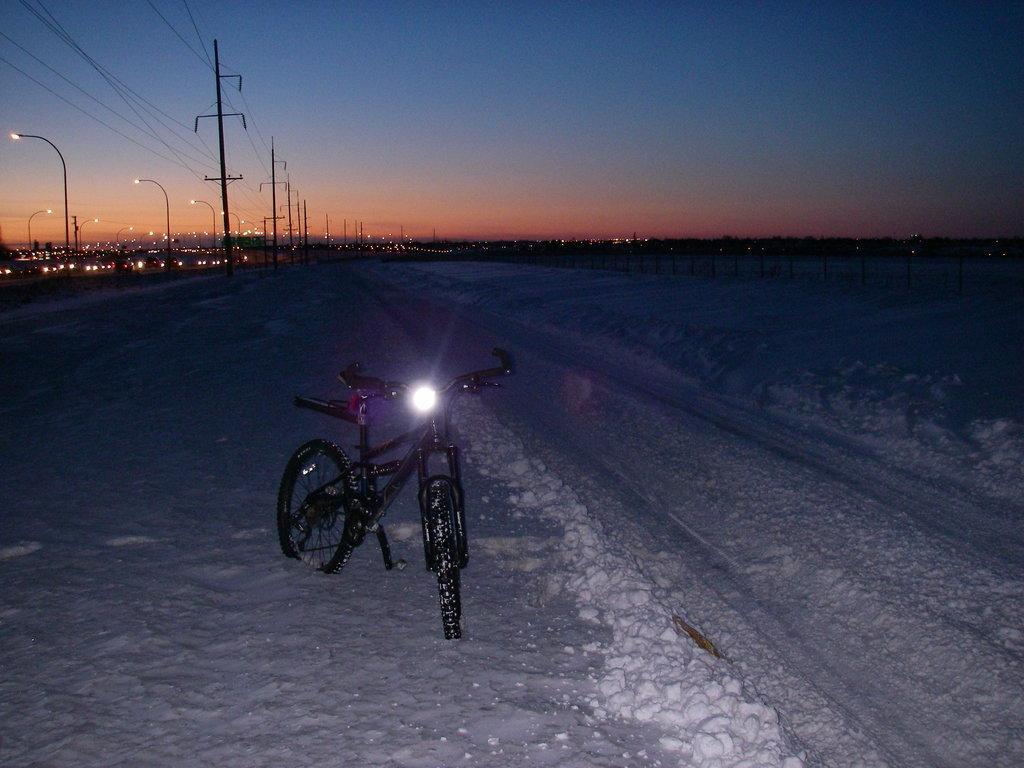In one or two sentences, can you explain what this image depicts? In the foreground of the picture we can see a bicycle and snow. Towards left there are street lights, current poles, cables and lights. On the right it is dark. At the top it is sky. 